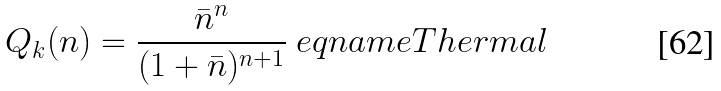Convert formula to latex. <formula><loc_0><loc_0><loc_500><loc_500>Q _ { k } ( n ) = \frac { { \bar { n } } ^ { n } } { ( 1 + { \bar { n } } ) ^ { n + 1 } } \ e q n a m e { T h e r m a l }</formula> 